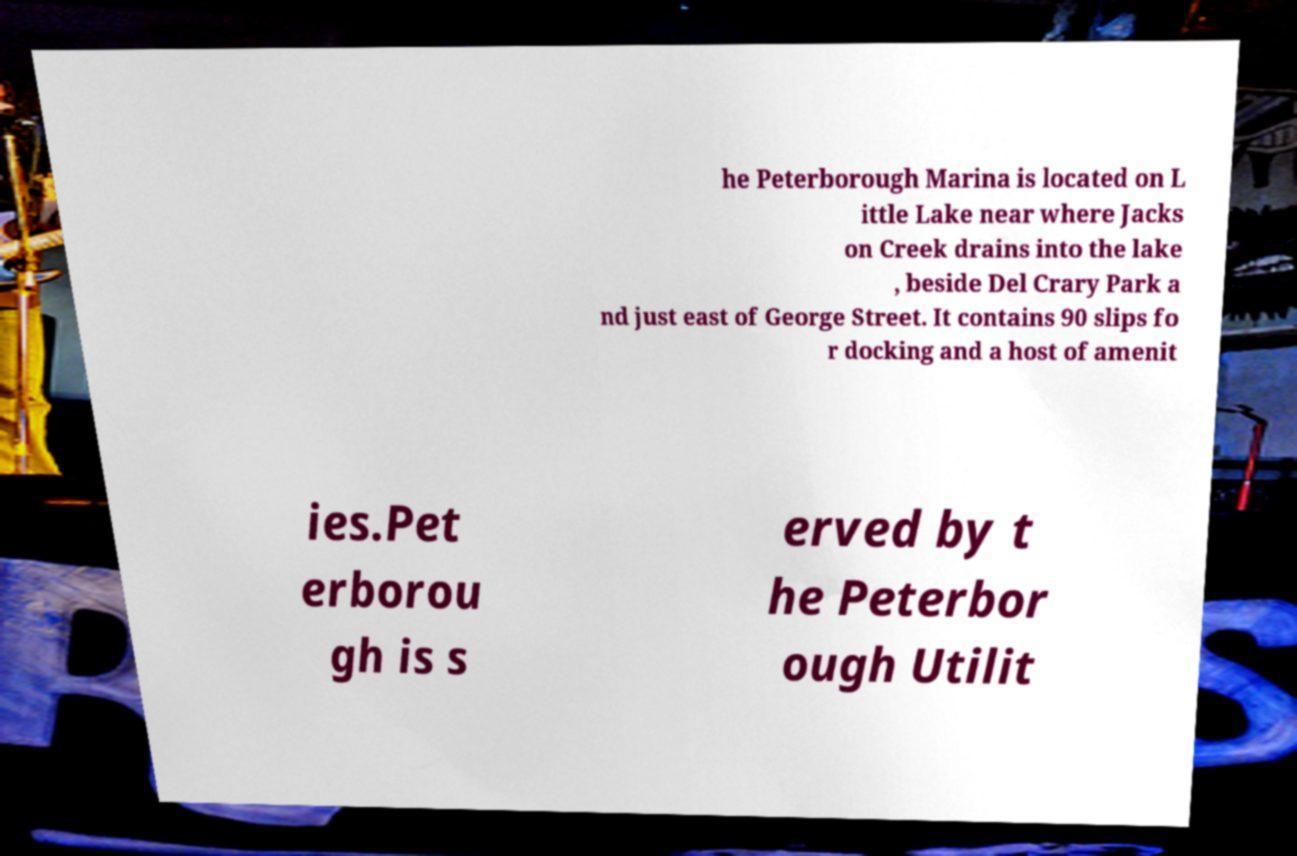Could you assist in decoding the text presented in this image and type it out clearly? he Peterborough Marina is located on L ittle Lake near where Jacks on Creek drains into the lake , beside Del Crary Park a nd just east of George Street. It contains 90 slips fo r docking and a host of amenit ies.Pet erborou gh is s erved by t he Peterbor ough Utilit 